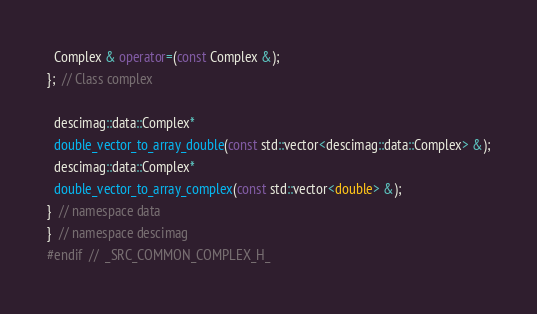<code> <loc_0><loc_0><loc_500><loc_500><_C++_>  Complex & operator=(const Complex &);
};  // Class complex

  descimag::data::Complex* 
  double_vector_to_array_double(const std::vector<descimag::data::Complex> &);
  descimag::data::Complex* 
  double_vector_to_array_complex(const std::vector<double> &);
}  // namespace data
}  // namespace descimag
#endif  //  _SRC_COMMON_COMPLEX_H_


</code> 